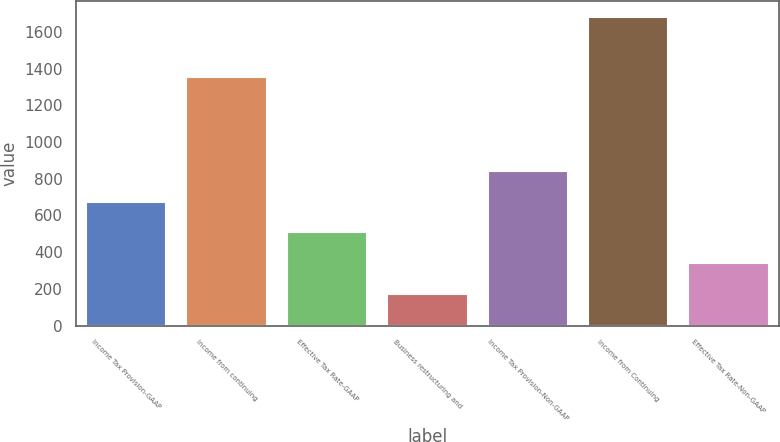Convert chart. <chart><loc_0><loc_0><loc_500><loc_500><bar_chart><fcel>Income Tax Provision-GAAP<fcel>Income from continuing<fcel>Effective Tax Rate-GAAP<fcel>Business restructuring and<fcel>Income Tax Provision-Non-GAAP<fcel>Income from Continuing<fcel>Effective Tax Rate-Non-GAAP<nl><fcel>675.82<fcel>1354.5<fcel>507.99<fcel>172.33<fcel>843.65<fcel>1682.8<fcel>340.16<nl></chart> 